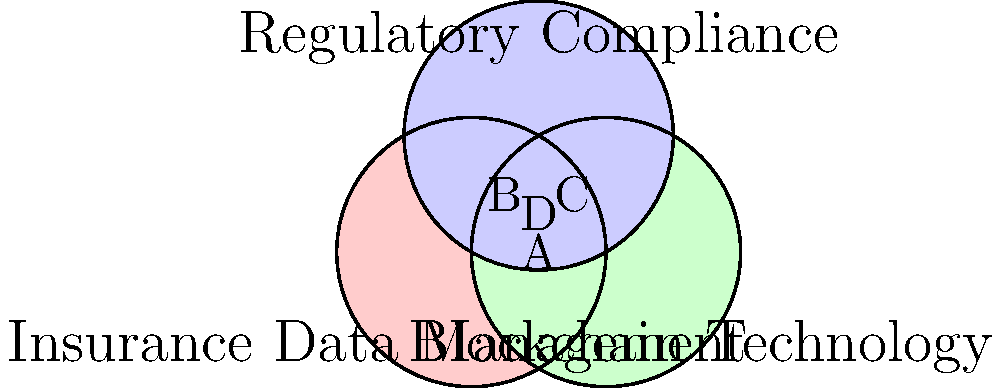In the Venn diagram above, which area represents the intersection of all three domains: insurance data management, blockchain technology, and regulatory compliance requirements? To answer this question, let's analyze the Venn diagram step-by-step:

1. The diagram consists of three overlapping circles, each representing one of the three domains:
   - Red circle: Insurance Data Management
   - Green circle: Blockchain Technology
   - Blue circle: Regulatory Compliance Requirements

2. The overlapping areas represent the intersections between these domains:
   - Area A: Intersection of Insurance Data Management and Blockchain Technology
   - Area B: Intersection of Insurance Data Management and Regulatory Compliance
   - Area C: Intersection of Blockchain Technology and Regulatory Compliance

3. The central area where all three circles overlap is labeled as D. This area represents the intersection of all three domains.

4. Area D is where insurance data management practices meet blockchain technology solutions while also satisfying regulatory compliance requirements.

5. This intersection is crucial for an insurance company executive looking to implement blockchain technology for secure data storage, as it represents the sweet spot where all three aspects are addressed simultaneously.

Therefore, the area that represents the intersection of all three domains is area D in the center of the Venn diagram.
Answer: D 